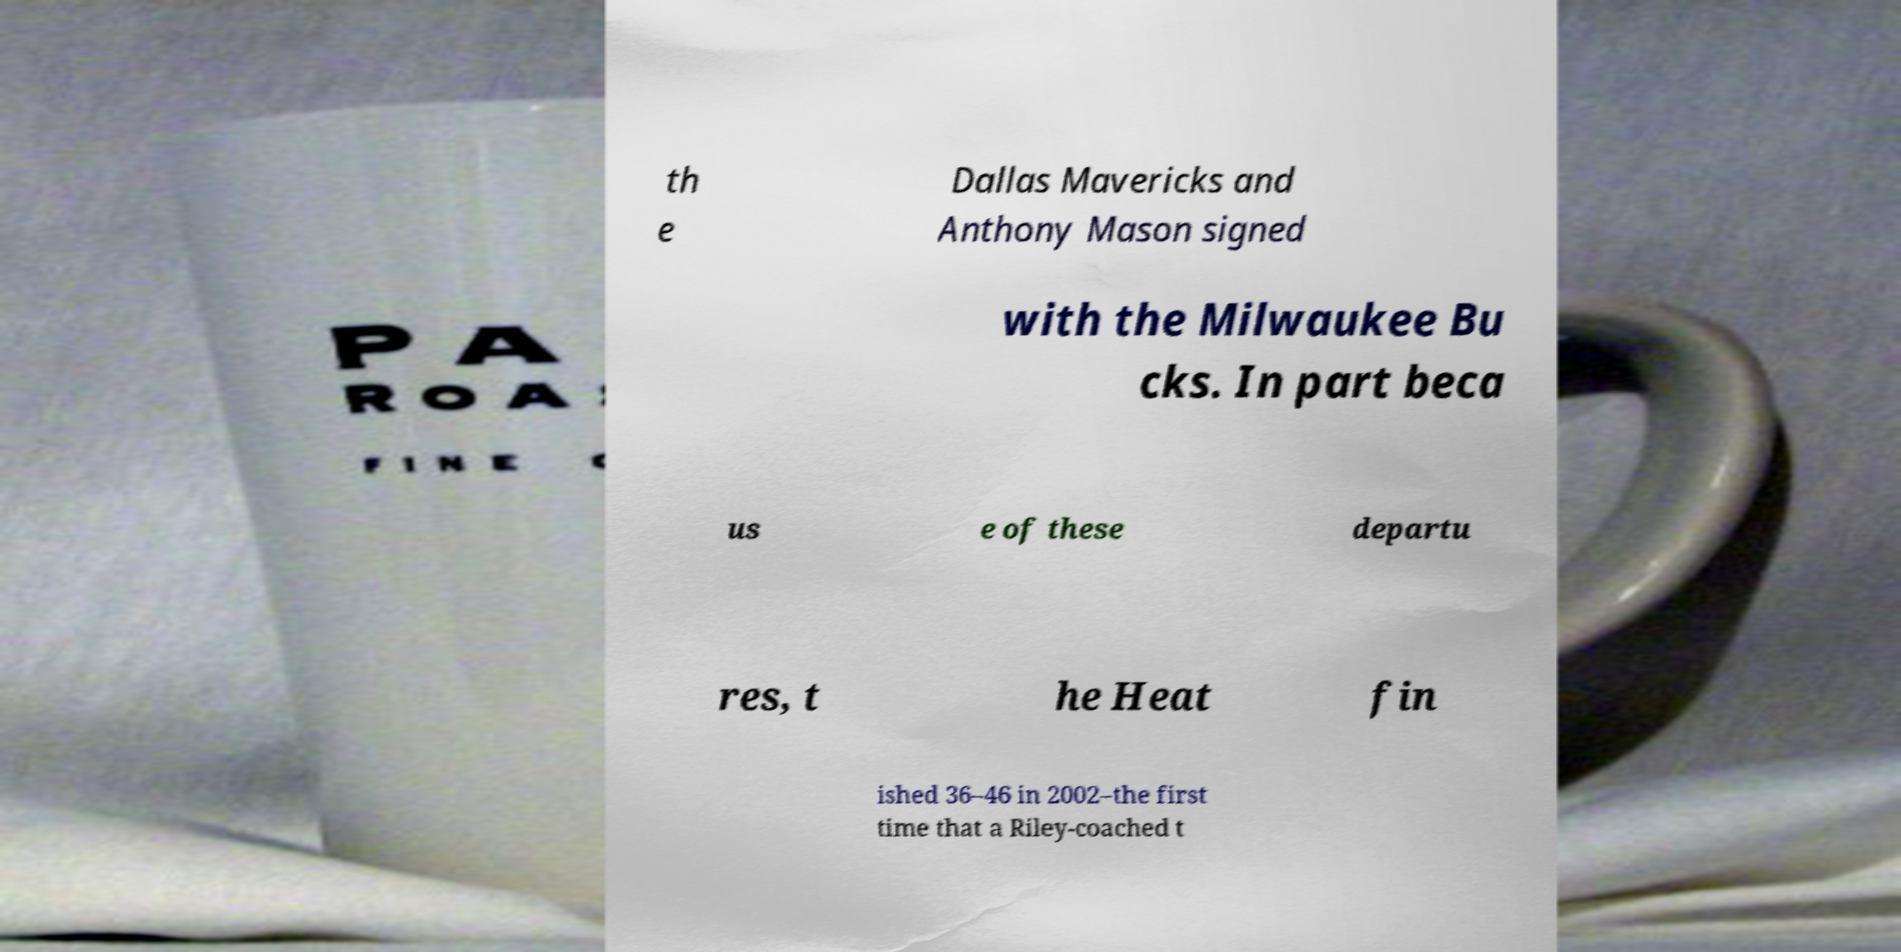Can you accurately transcribe the text from the provided image for me? th e Dallas Mavericks and Anthony Mason signed with the Milwaukee Bu cks. In part beca us e of these departu res, t he Heat fin ished 36–46 in 2002–the first time that a Riley-coached t 